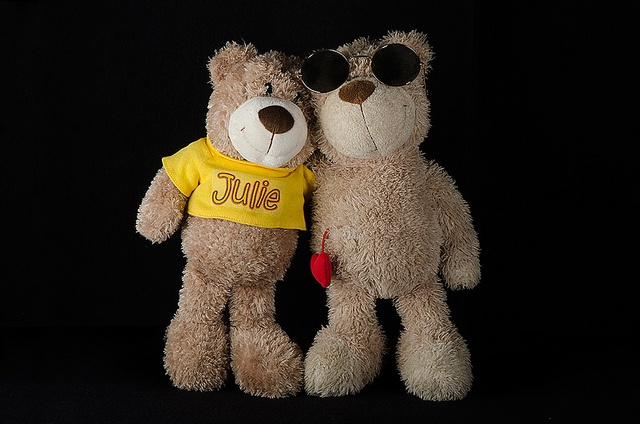Describe the objects in this image and their specific colors. I can see teddy bear in black and gray tones and teddy bear in black, gray, tan, darkgray, and maroon tones in this image. 